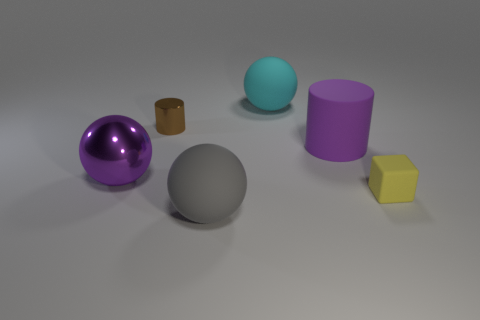What material is the big object that is in front of the tiny yellow object?
Give a very brief answer. Rubber. There is a purple object that is on the left side of the big matte sphere behind the small yellow rubber cube; what is its shape?
Provide a succinct answer. Sphere. There is a small brown object; is its shape the same as the purple thing that is to the left of the big cyan object?
Your answer should be very brief. No. How many tiny metal things are behind the small object right of the big cyan ball?
Your answer should be compact. 1. There is a large purple thing that is the same shape as the small brown shiny object; what is it made of?
Your answer should be compact. Rubber. What number of brown things are either large shiny objects or tiny objects?
Offer a very short reply. 1. Are there any other things that have the same color as the block?
Ensure brevity in your answer.  No. The large rubber sphere that is behind the tiny thing to the left of the big gray matte thing is what color?
Keep it short and to the point. Cyan. Is the number of big purple things that are right of the cyan rubber thing less than the number of big purple shiny things that are left of the tiny brown cylinder?
Provide a short and direct response. No. There is a thing that is the same color as the large matte cylinder; what is its material?
Offer a very short reply. Metal. 